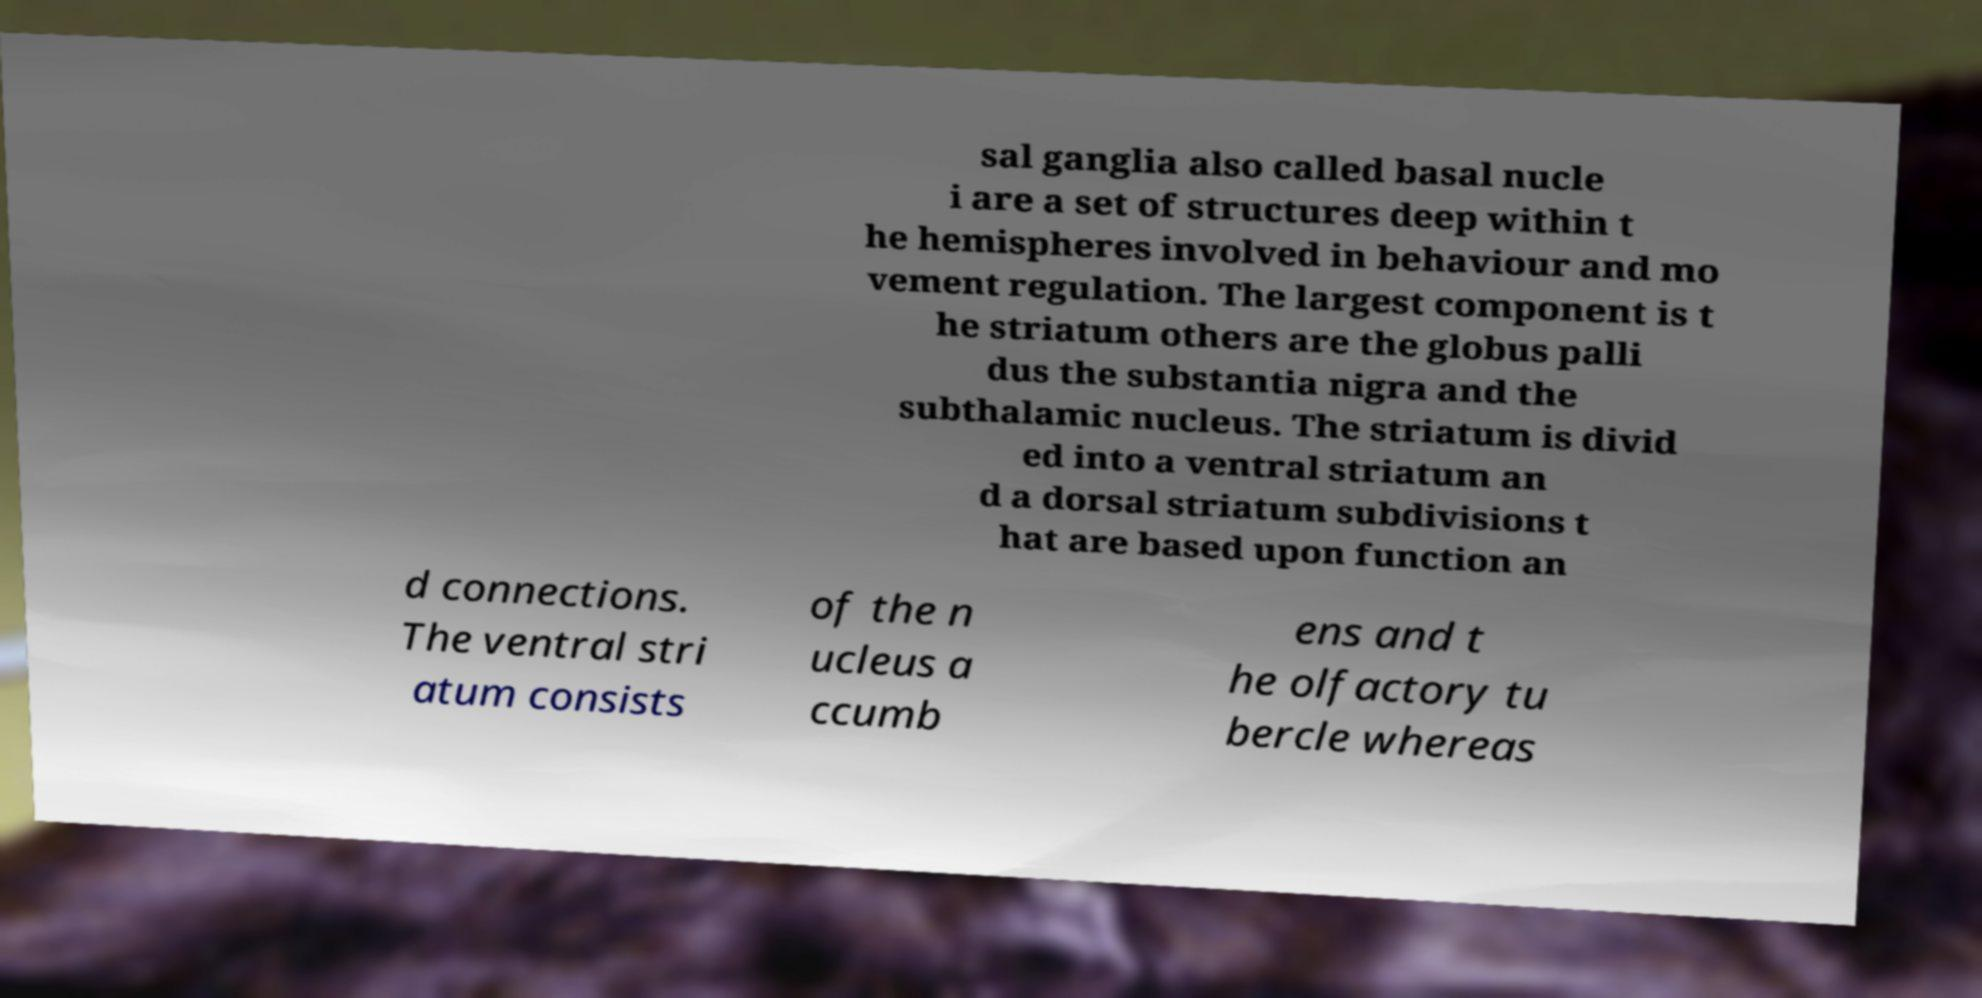I need the written content from this picture converted into text. Can you do that? sal ganglia also called basal nucle i are a set of structures deep within t he hemispheres involved in behaviour and mo vement regulation. The largest component is t he striatum others are the globus palli dus the substantia nigra and the subthalamic nucleus. The striatum is divid ed into a ventral striatum an d a dorsal striatum subdivisions t hat are based upon function an d connections. The ventral stri atum consists of the n ucleus a ccumb ens and t he olfactory tu bercle whereas 